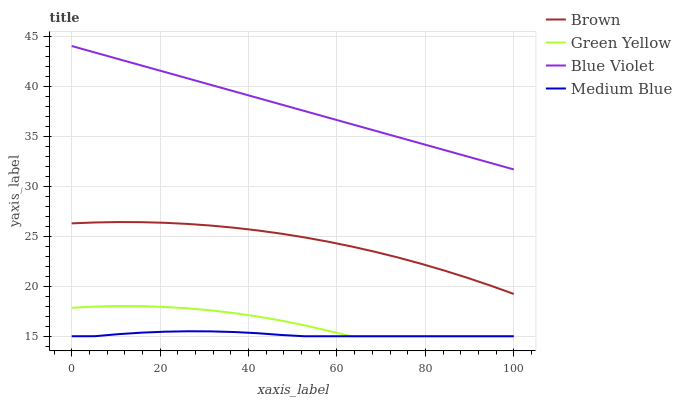Does Medium Blue have the minimum area under the curve?
Answer yes or no. Yes. Does Blue Violet have the maximum area under the curve?
Answer yes or no. Yes. Does Green Yellow have the minimum area under the curve?
Answer yes or no. No. Does Green Yellow have the maximum area under the curve?
Answer yes or no. No. Is Blue Violet the smoothest?
Answer yes or no. Yes. Is Green Yellow the roughest?
Answer yes or no. Yes. Is Medium Blue the smoothest?
Answer yes or no. No. Is Medium Blue the roughest?
Answer yes or no. No. Does Green Yellow have the lowest value?
Answer yes or no. Yes. Does Blue Violet have the lowest value?
Answer yes or no. No. Does Blue Violet have the highest value?
Answer yes or no. Yes. Does Green Yellow have the highest value?
Answer yes or no. No. Is Medium Blue less than Blue Violet?
Answer yes or no. Yes. Is Blue Violet greater than Medium Blue?
Answer yes or no. Yes. Does Medium Blue intersect Green Yellow?
Answer yes or no. Yes. Is Medium Blue less than Green Yellow?
Answer yes or no. No. Is Medium Blue greater than Green Yellow?
Answer yes or no. No. Does Medium Blue intersect Blue Violet?
Answer yes or no. No. 